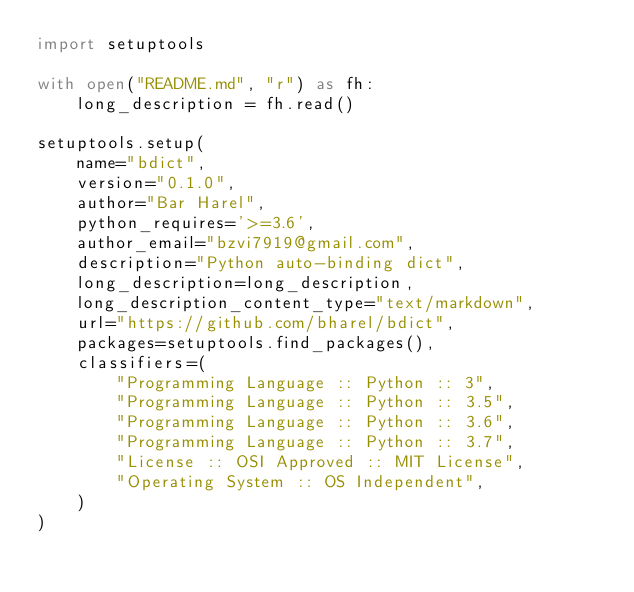Convert code to text. <code><loc_0><loc_0><loc_500><loc_500><_Python_>import setuptools

with open("README.md", "r") as fh:
    long_description = fh.read()

setuptools.setup(
    name="bdict",
    version="0.1.0",
    author="Bar Harel",
    python_requires='>=3.6',
    author_email="bzvi7919@gmail.com",
    description="Python auto-binding dict",
    long_description=long_description,
    long_description_content_type="text/markdown",
    url="https://github.com/bharel/bdict",
    packages=setuptools.find_packages(),
    classifiers=(
        "Programming Language :: Python :: 3",
        "Programming Language :: Python :: 3.5",
        "Programming Language :: Python :: 3.6",
        "Programming Language :: Python :: 3.7",
        "License :: OSI Approved :: MIT License",
        "Operating System :: OS Independent",
    )
)
</code> 